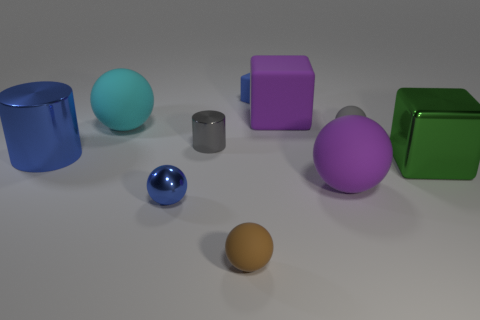Subtract all shiny blocks. How many blocks are left? 2 Subtract all gray cylinders. How many cylinders are left? 1 Subtract all cylinders. How many objects are left? 8 Subtract all cyan balls. Subtract all gray cylinders. How many balls are left? 4 Subtract all blue cylinders. How many blue blocks are left? 1 Subtract all green metal cubes. Subtract all small brown matte objects. How many objects are left? 8 Add 6 big blue objects. How many big blue objects are left? 7 Add 8 small red shiny blocks. How many small red shiny blocks exist? 8 Subtract 0 yellow cylinders. How many objects are left? 10 